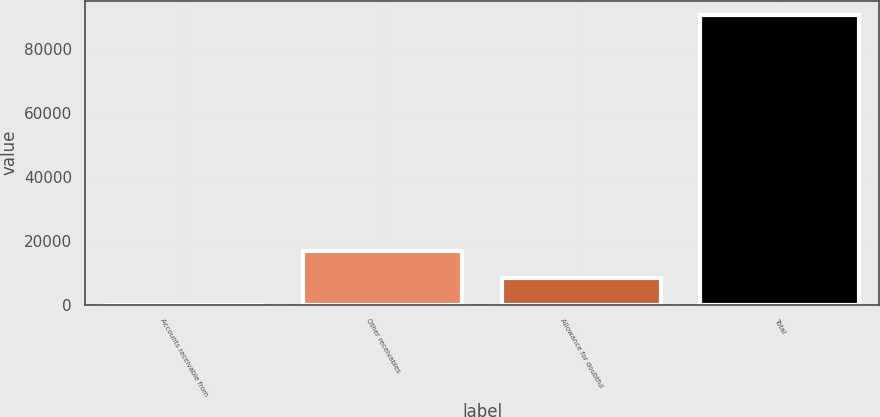Convert chart. <chart><loc_0><loc_0><loc_500><loc_500><bar_chart><fcel>Accounts receivable from<fcel>Other receivables<fcel>Allowance for doubtful<fcel>Total<nl><fcel>15<fcel>16635.8<fcel>8325.4<fcel>90454.4<nl></chart> 